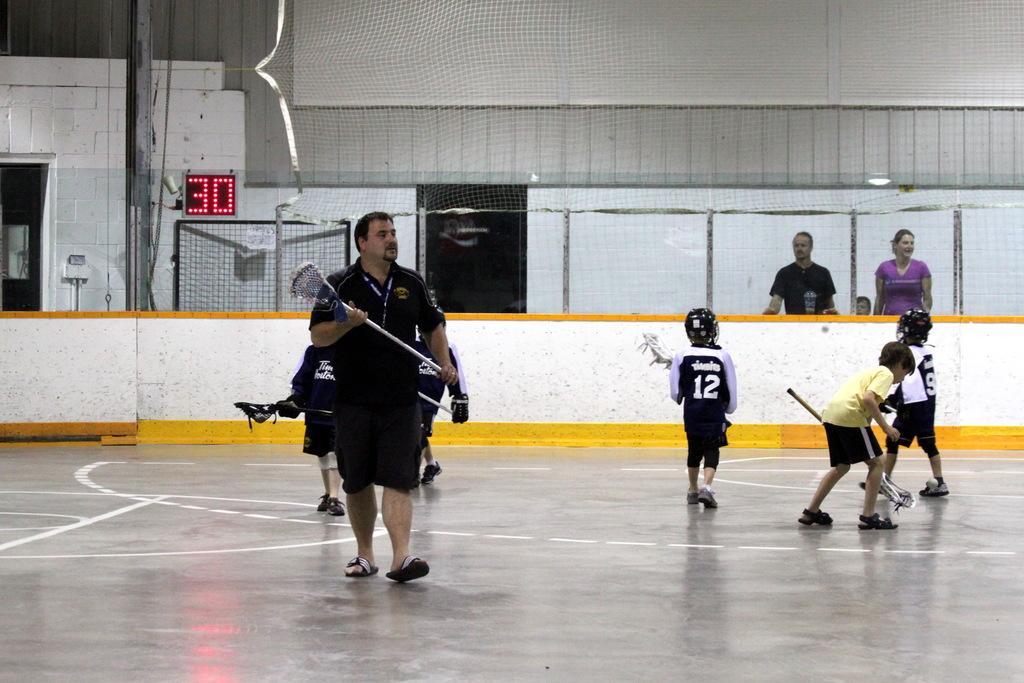In one or two sentences, can you explain what this image depicts? In this image I see few children and a man who are holding sticks and they're on the floor. In the background I see the wall which is of white and yellow in color and I see the net and screen on which there are 2 numbers and I see women and another man over here and I see the light over here. 